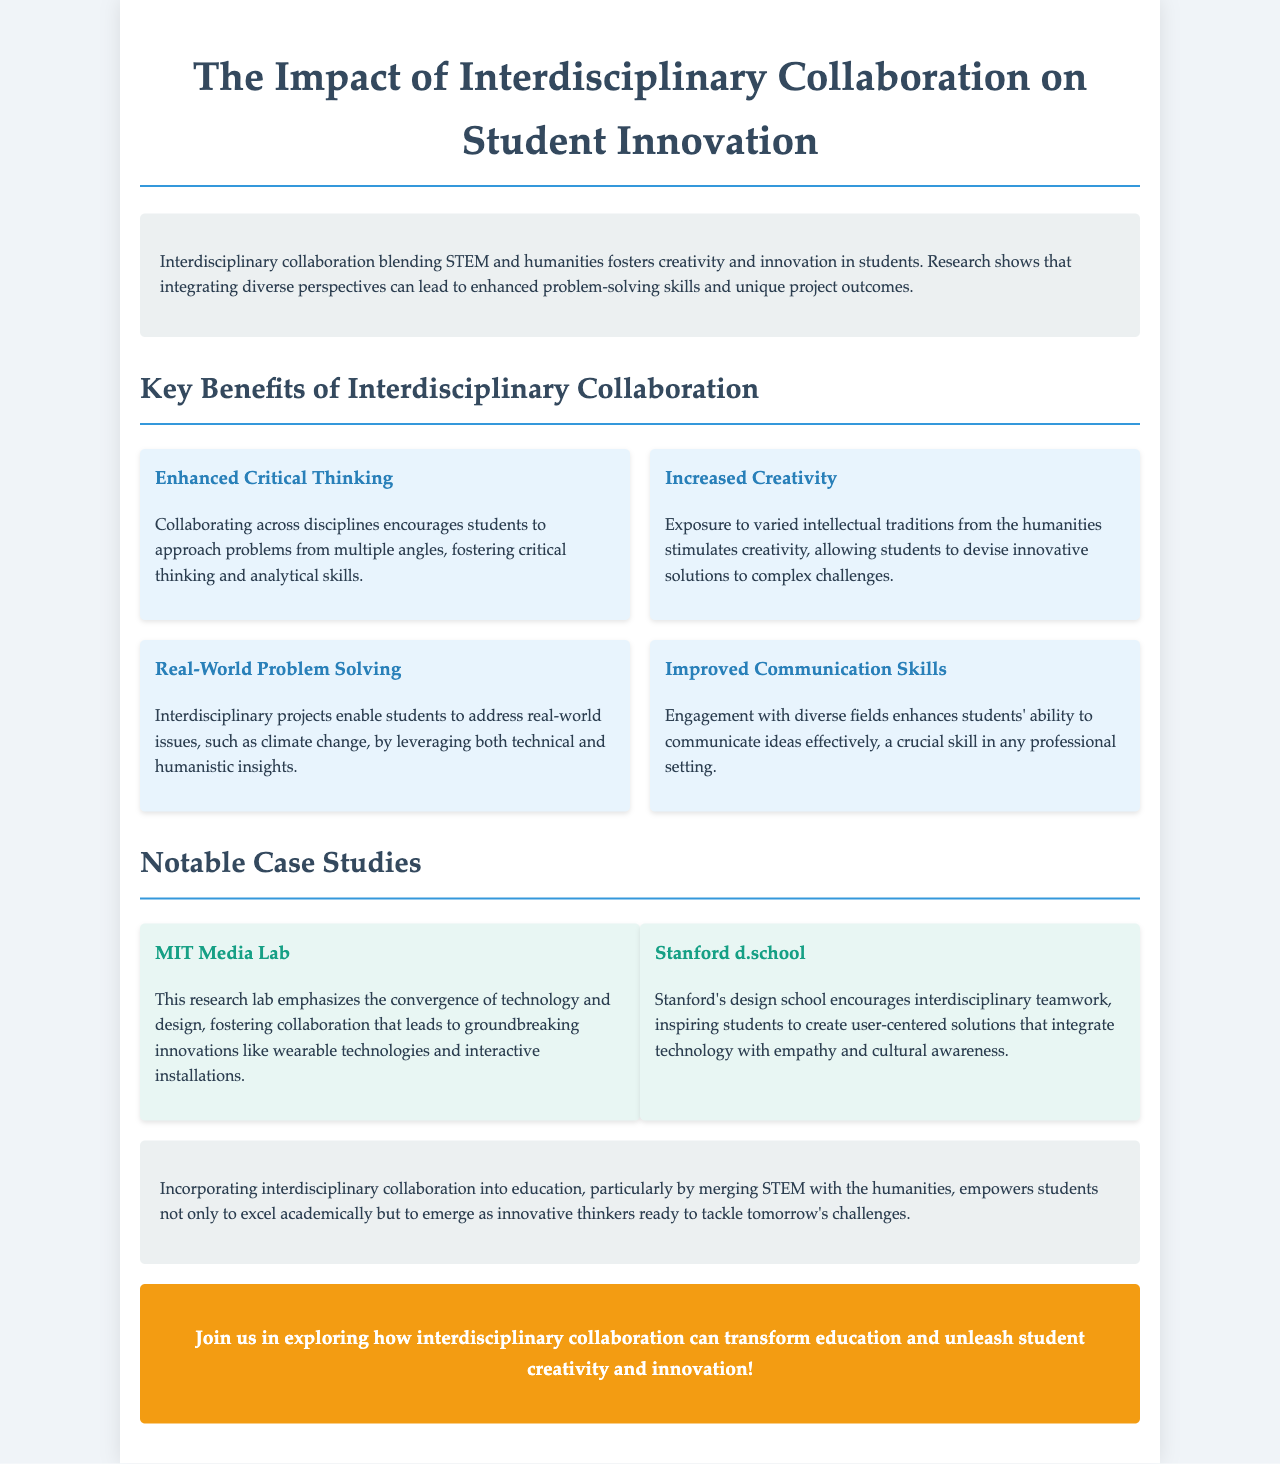What is the main focus of the brochure? The brochure focuses on the impact of interdisciplinary collaboration on student innovation, particularly blending STEM and humanities.
Answer: Interdisciplinary collaboration on student innovation What are two notable case studies mentioned? The brochure lists MIT Media Lab and Stanford d.school as notable case studies that exemplify interdisciplinary collaboration.
Answer: MIT Media Lab, Stanford d.school What benefit is associated with improved communication skills? Improved communication skills enhance students' ability to effectively communicate ideas, which is crucial in any professional setting.
Answer: Effective communication How many key benefits of interdisciplinary collaboration are highlighted? The document highlights four key benefits of interdisciplinary collaboration for students.
Answer: Four What type of project does interdisciplinary collaboration enable students to address? The document states that interdisciplinary projects enable students to address real-world issues.
Answer: Real-world issues What is the color of the call-to-action section? The call-to-action section has a background color of orange, specifically '#f39c12'.
Answer: Orange What does the introduction suggest about research on interdisciplinary collaboration? The introduction suggests that research shows integrating diverse perspectives leads to enhanced problem-solving skills and unique project outcomes.
Answer: Enhanced problem-solving skills What is one way interdisciplinary collaboration fosters creativity? Exposure to varied intellectual traditions from the humanities stimulates creativity in students.
Answer: Exposure to varied intellectual traditions What should readers do according to the call-to-action? The call-to-action encourages readers to join in exploring how interdisciplinary collaboration can transform education.
Answer: Join in exploring interdisciplinary collaboration 